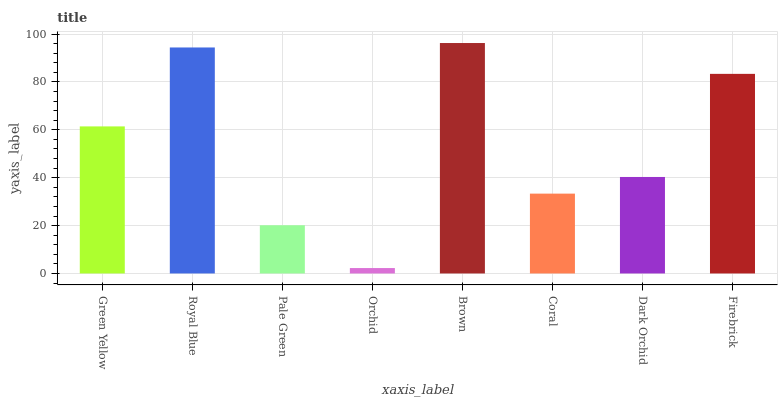Is Orchid the minimum?
Answer yes or no. Yes. Is Brown the maximum?
Answer yes or no. Yes. Is Royal Blue the minimum?
Answer yes or no. No. Is Royal Blue the maximum?
Answer yes or no. No. Is Royal Blue greater than Green Yellow?
Answer yes or no. Yes. Is Green Yellow less than Royal Blue?
Answer yes or no. Yes. Is Green Yellow greater than Royal Blue?
Answer yes or no. No. Is Royal Blue less than Green Yellow?
Answer yes or no. No. Is Green Yellow the high median?
Answer yes or no. Yes. Is Dark Orchid the low median?
Answer yes or no. Yes. Is Firebrick the high median?
Answer yes or no. No. Is Firebrick the low median?
Answer yes or no. No. 